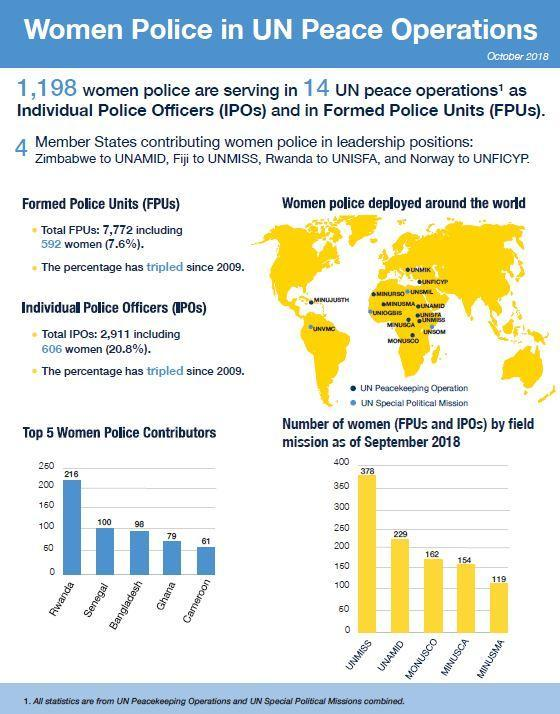Which UN mission deployed highest number of women (FPUs & IPOs) as of September 2018?
Answer the question with a short phrase. UNMISS Which country has the highest number of women police contributors in UN peace operations as of October 2018? Rwanda Which UN mission deployed least number of women (FPUs & IPOs) as of September 2018? MINUSMA How many women (FPUs & IPOs) were deployed in Monusco mission as of September 2018? 162 What is the number of women police contributors in UN peace operations in Ghana as of October 2018? 79 How many women (FPUs & IPOs) were deployed in MINUSMA mission as of September 2018? 119 